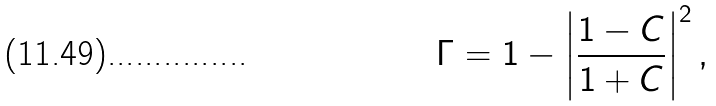<formula> <loc_0><loc_0><loc_500><loc_500>\Gamma & = 1 - \left | \frac { 1 - C } { 1 + C } \right | ^ { 2 } ,</formula> 